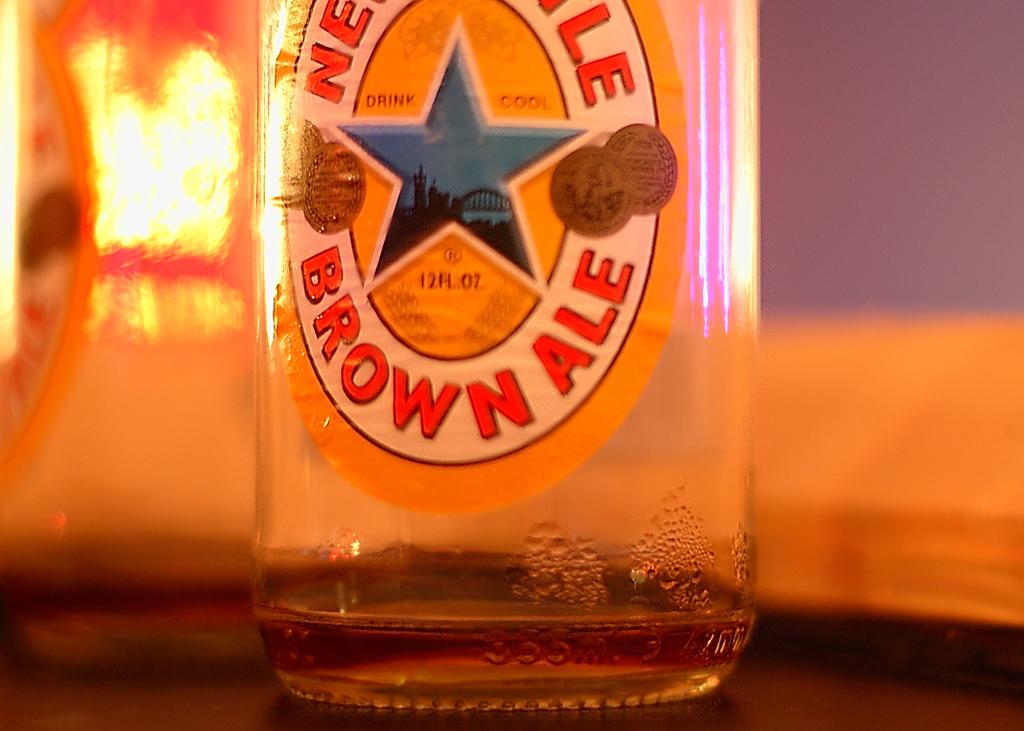Is this an empty bottle of brown ale?
Provide a short and direct response. Yes. What kind of beer is this/?
Offer a terse response. Brown ale. 